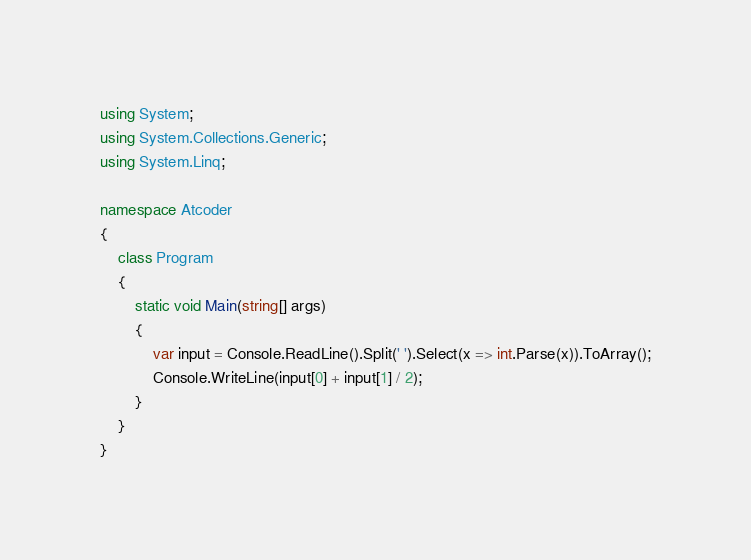<code> <loc_0><loc_0><loc_500><loc_500><_C#_>using System;
using System.Collections.Generic;
using System.Linq;

namespace Atcoder
{
    class Program
    {
        static void Main(string[] args)
        {
            var input = Console.ReadLine().Split(' ').Select(x => int.Parse(x)).ToArray();
            Console.WriteLine(input[0] + input[1] / 2);
        }
    }
}</code> 